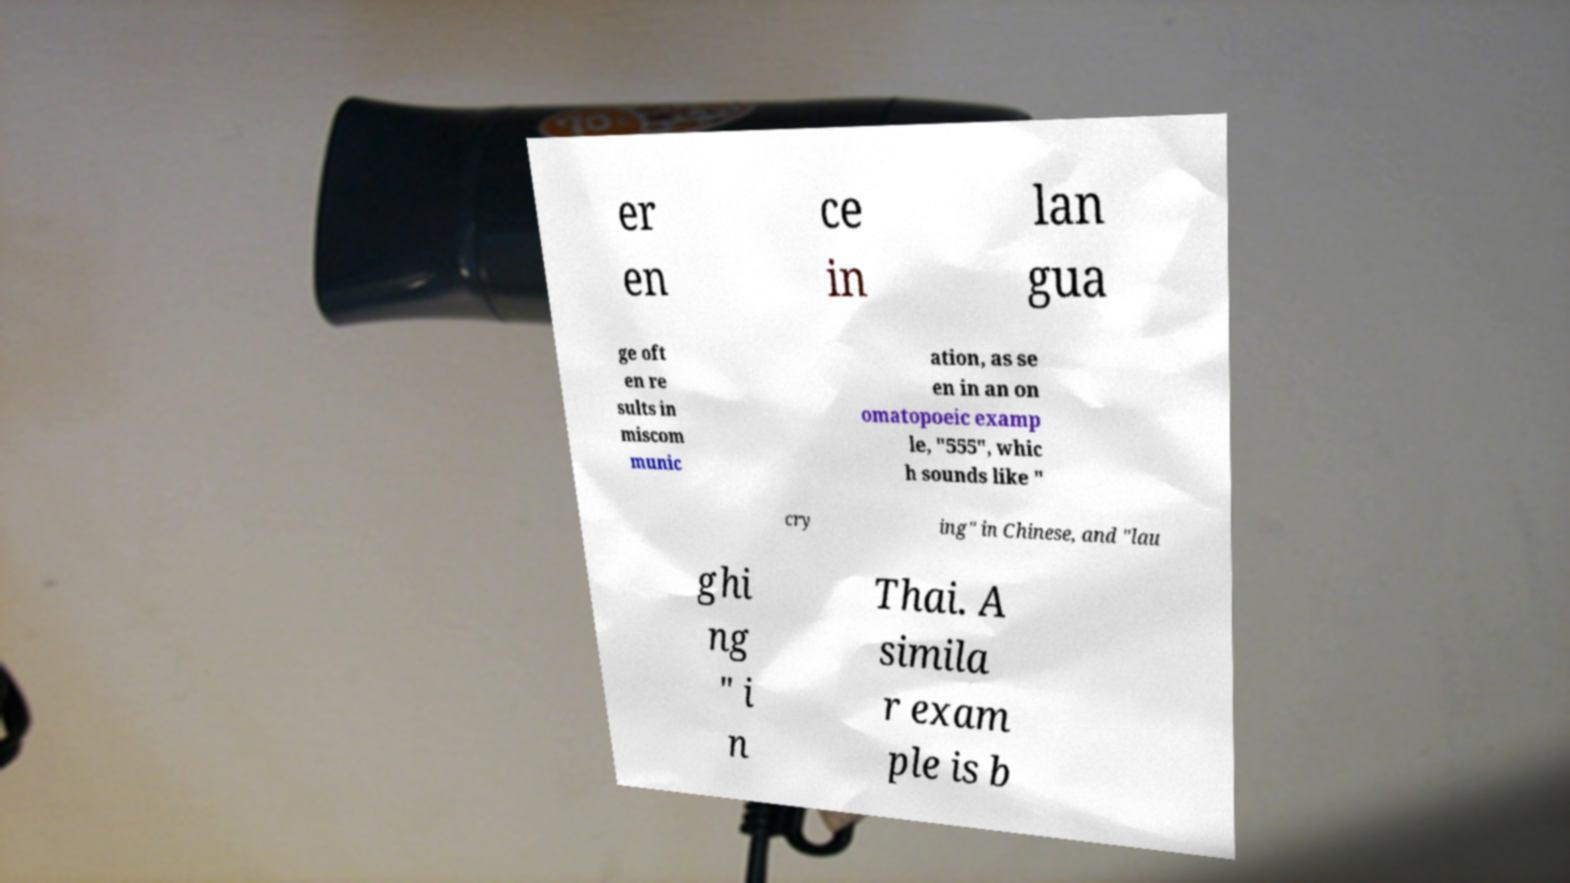Could you extract and type out the text from this image? er en ce in lan gua ge oft en re sults in miscom munic ation, as se en in an on omatopoeic examp le, "555", whic h sounds like " cry ing" in Chinese, and "lau ghi ng " i n Thai. A simila r exam ple is b 